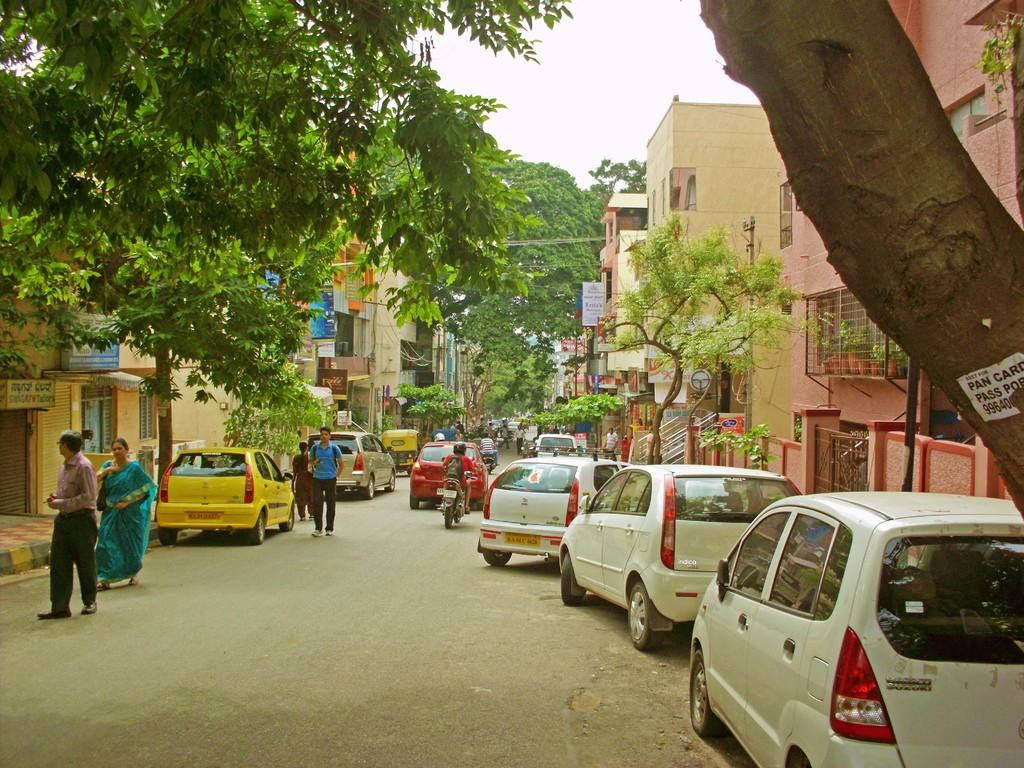What type of structures can be seen in the image? There are buildings in the image. What architectural features can be observed on the buildings? There are windows visible on the buildings. Who or what can be seen in the image? There are people in the image. What type of transportation is present in the image? There are vehicles in the image. What other objects can be seen in the image? There are wires, trees, a gate, flower pots, and boards present in the image. What type of businesses might be present in the image? There are stores in the image. What is the color of the sky in the image? The sky is white in color. Can you see a drum being played by a bun in the image? There is no drum or bun present in the image. Is there a trampoline visible in the image? There is no trampoline present in the image. 